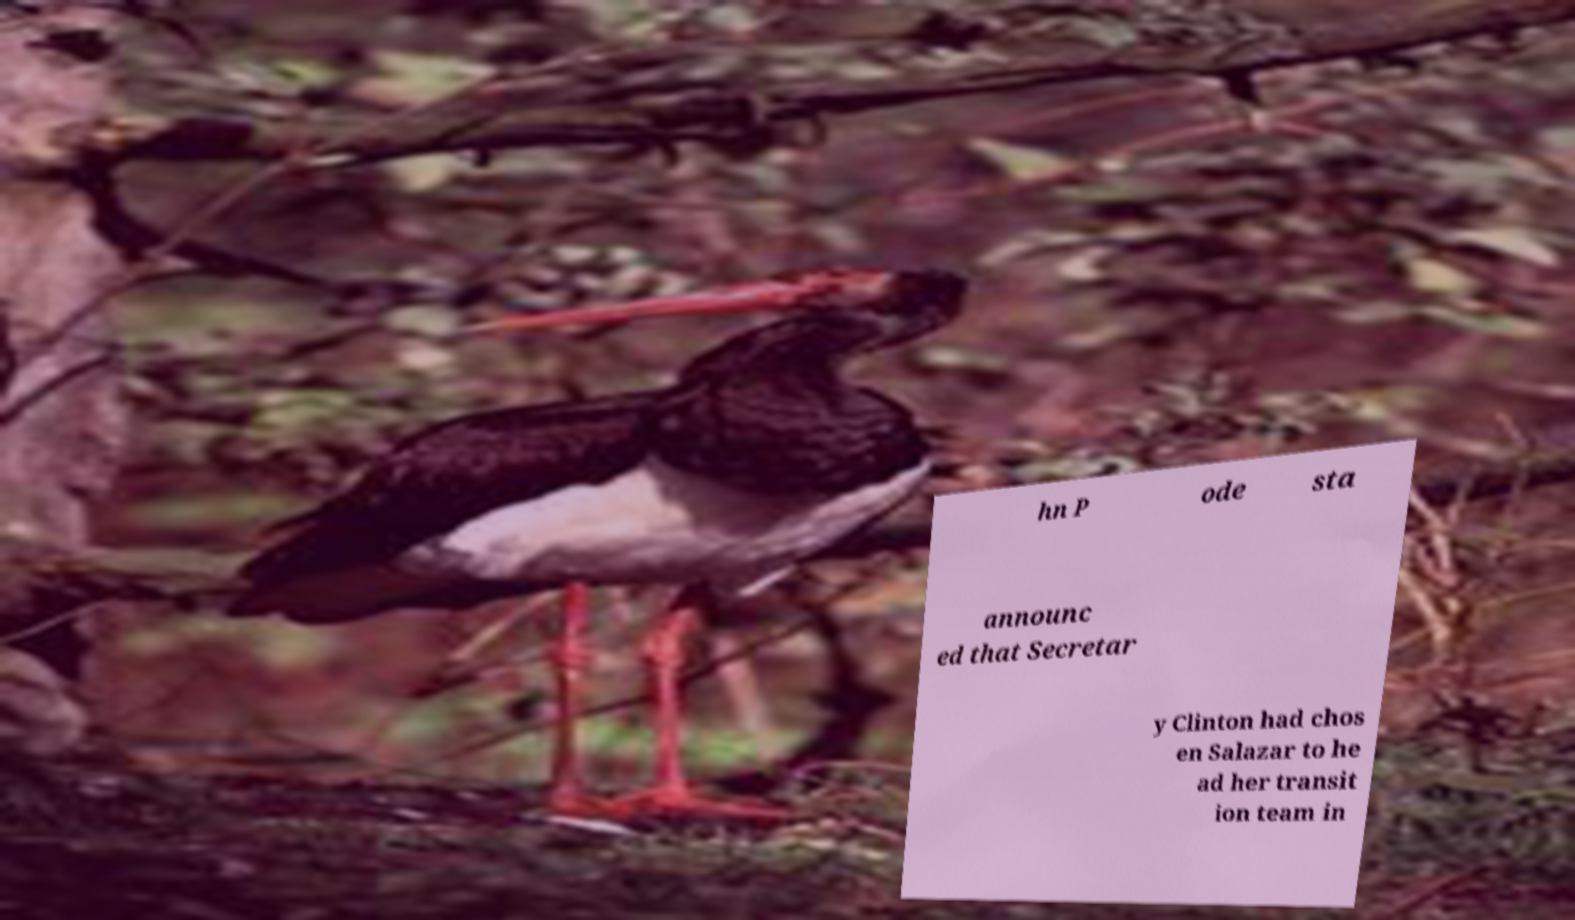Can you read and provide the text displayed in the image?This photo seems to have some interesting text. Can you extract and type it out for me? hn P ode sta announc ed that Secretar y Clinton had chos en Salazar to he ad her transit ion team in 